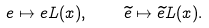<formula> <loc_0><loc_0><loc_500><loc_500>e \mapsto e L ( x ) , \quad \widetilde { e } \mapsto \widetilde { e } L ( x ) .</formula> 